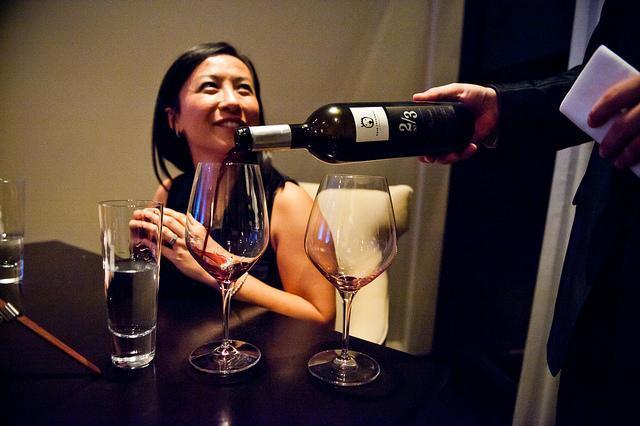How many glasses of water are in the picture?
Give a very brief answer. 2. How many wine glasses are there?
Give a very brief answer. 2. How many people are there?
Give a very brief answer. 2. How many cups can be seen?
Give a very brief answer. 2. How many of the dogs have black spots?
Give a very brief answer. 0. 